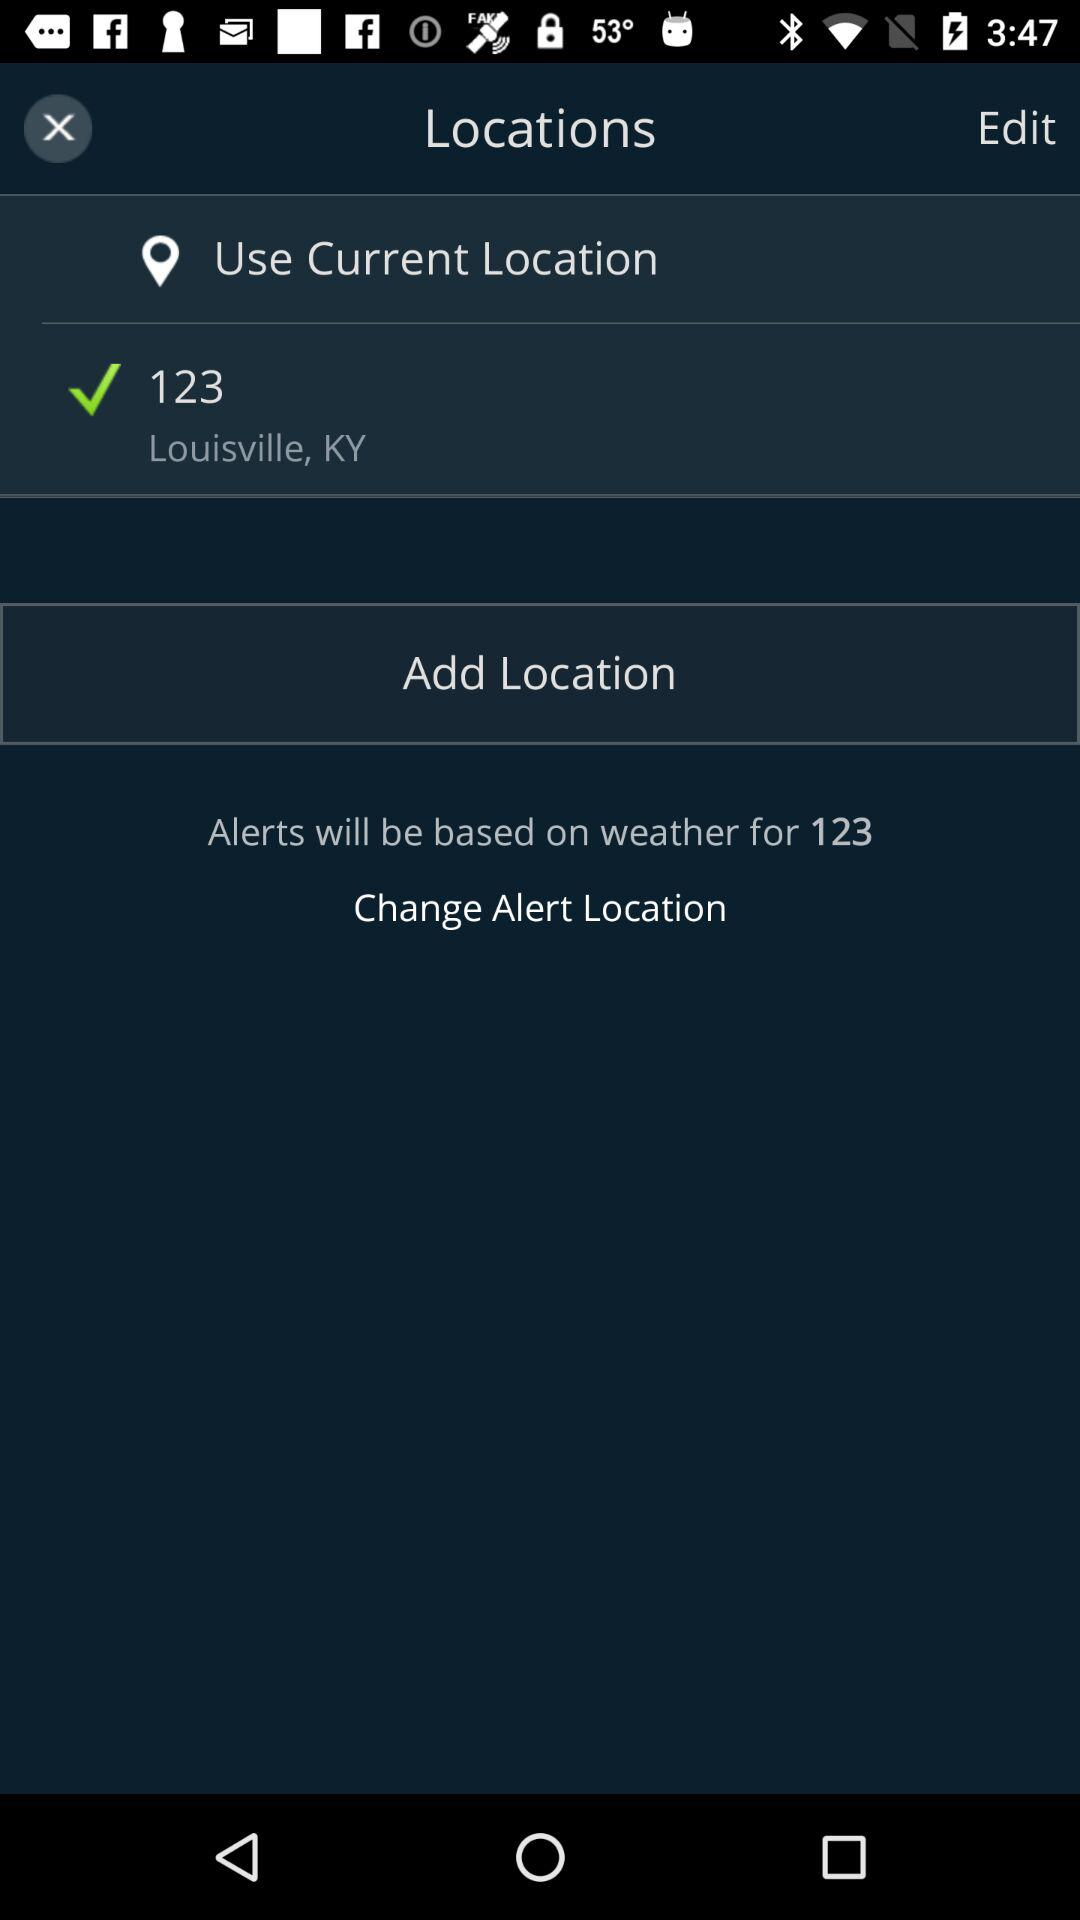What is the current location? The current location is Louisville, KY. 